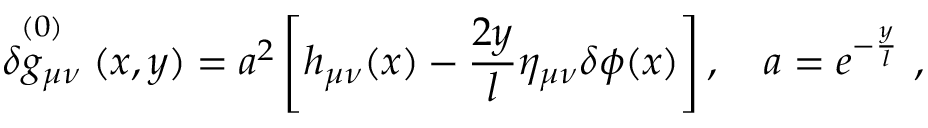Convert formula to latex. <formula><loc_0><loc_0><loc_500><loc_500>\stackrel { ( 0 ) } { \delta g _ { \mu \nu } } ( x , y ) = a ^ { 2 } \left [ h _ { \mu \nu } ( x ) - \frac { 2 y } { l } \eta _ { \mu \nu } \delta \phi ( x ) \right ] , \quad a = e ^ { - \frac { y } { l } } \ ,</formula> 